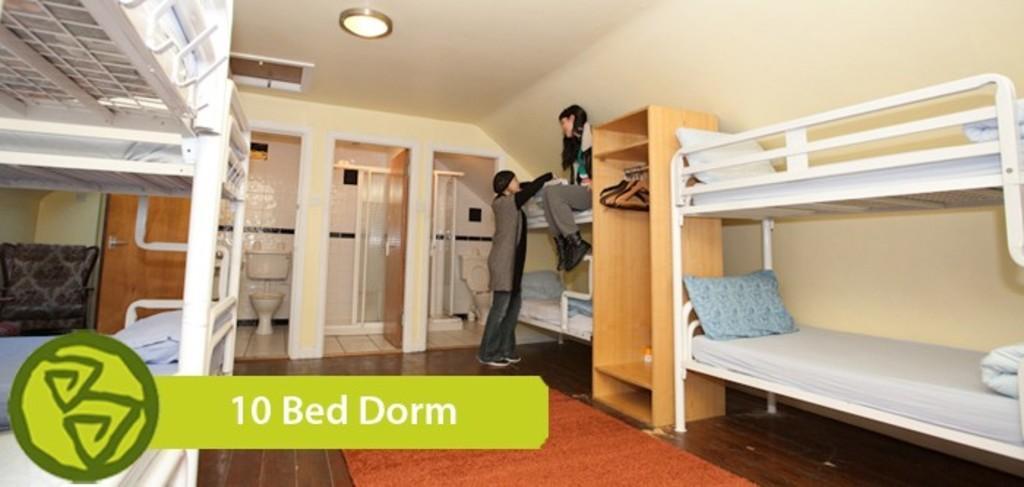Describe this image in one or two sentences. This picture is clicked inside the room. On both the sides we can see the white color bunk beds and we can see the pillows and blankets and we can see the cabinet and the hangers and there is a person sitting on the bed and a person standing on the floor and we can see the floor carpet. At the top there is a roof and the ceiling light. In the background we can see the wall, wooden doors, toilets and some other objects. In the bottom left corner we can see the watermark on the image. 